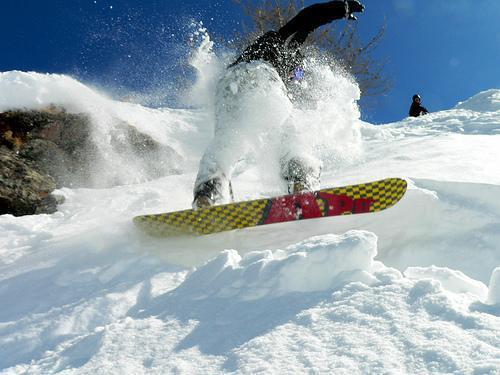How many snowboarders are there?
Give a very brief answer. 1. 